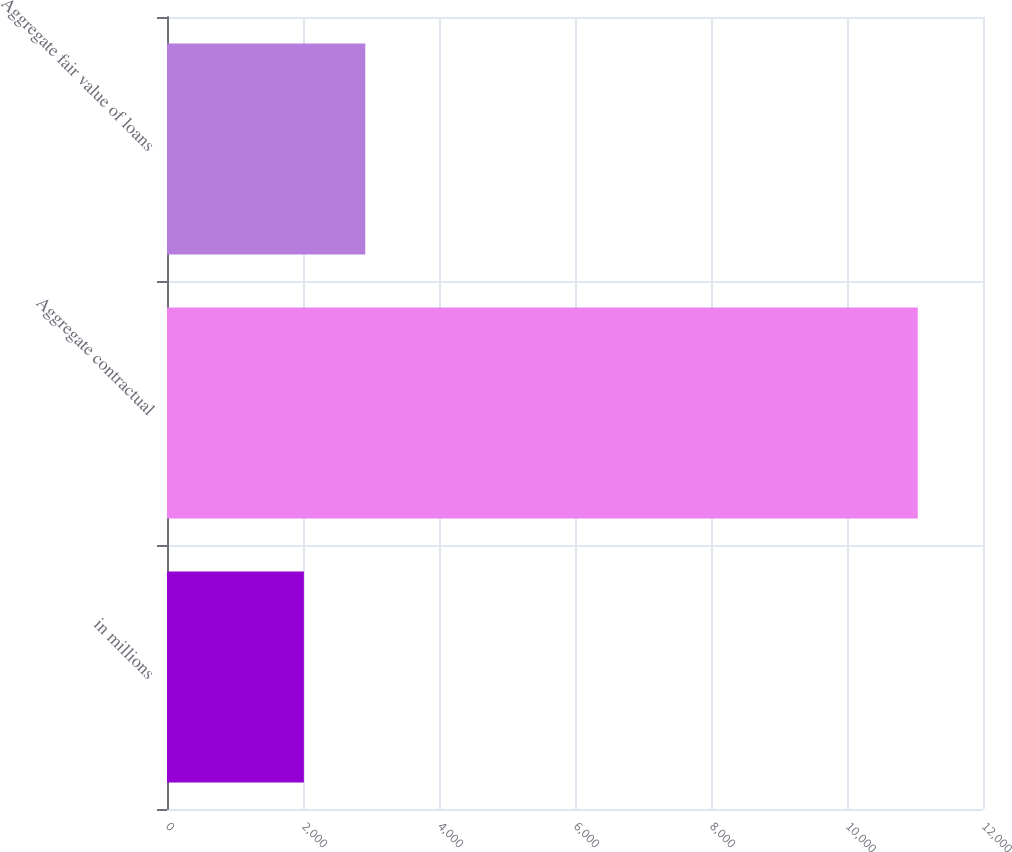Convert chart to OTSL. <chart><loc_0><loc_0><loc_500><loc_500><bar_chart><fcel>in millions<fcel>Aggregate contractual<fcel>Aggregate fair value of loans<nl><fcel>2013<fcel>11041<fcel>2915.8<nl></chart> 